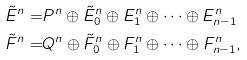<formula> <loc_0><loc_0><loc_500><loc_500>\tilde { E } ^ { n } = & P ^ { n } \oplus \tilde { E } _ { 0 } ^ { n } \oplus E ^ { n } _ { 1 } \oplus \dots \oplus E ^ { n } _ { n - 1 } \\ \tilde { F } ^ { n } = & Q ^ { n } \oplus \tilde { F } _ { 0 } ^ { n } \oplus F ^ { n } _ { 1 } \oplus \dots \oplus F ^ { n } _ { n - 1 } ,</formula> 